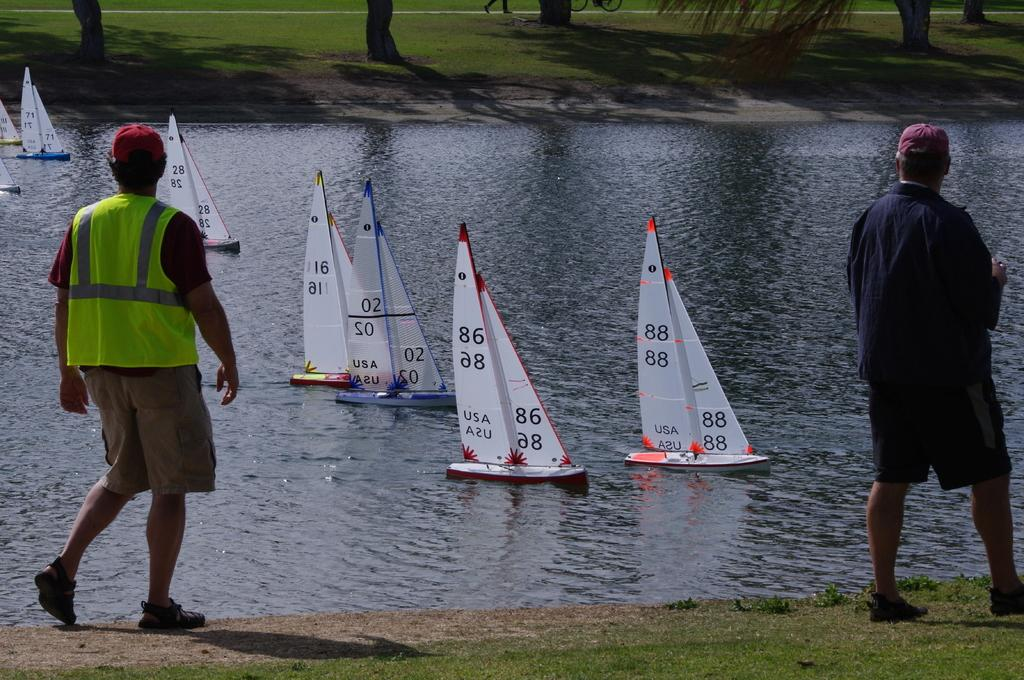How many people are in the image? There are two persons standing in the image. What type of terrain is visible in the image? There is grass visible in the image. What type of vehicles are present in the image? There are boats in the image. What body of water is visible in the image? There is water visible in the image. What type of toy can be seen being used by the persons in the image? There is no toy visible in the image; it features two persons standing near boats and water. How is the kettle being used in the image? There is no kettle present in the image. 